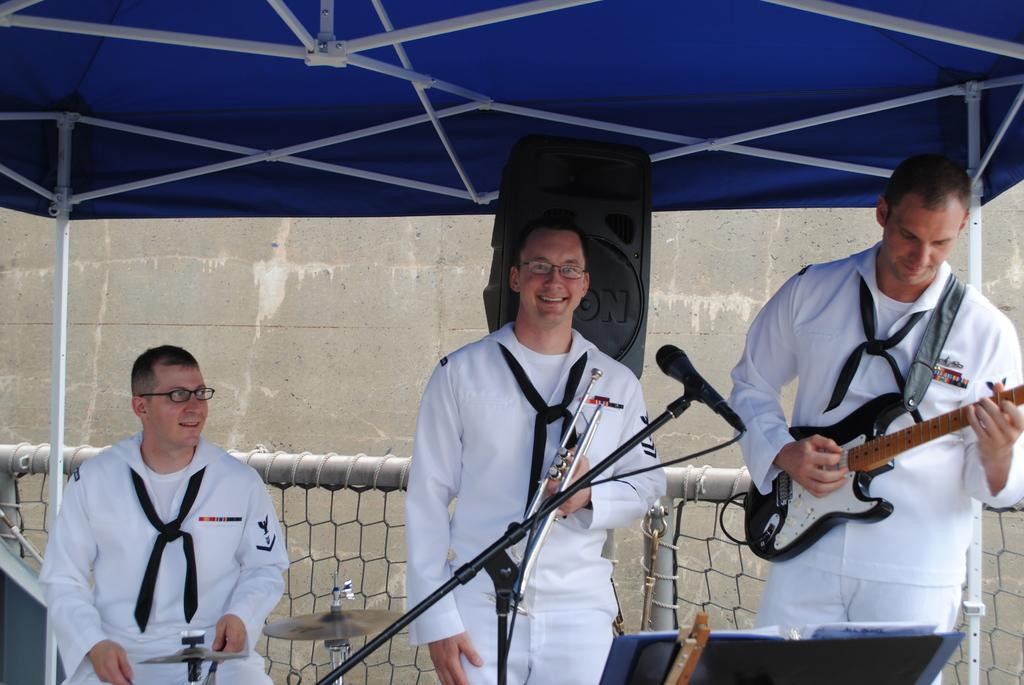How many people are in the image? There are three persons in the image. What are the persons doing in the image? The persons are playing musical instruments. Can you describe any equipment related to sound in the image? Yes, there is a microphone in the image. What can be seen in the background of the image? There is a wall and a mesh in the background of the image. Is there a fight happening between the persons in the image? No, there is no fight depicted in the image; the persons are playing musical instruments. What type of poison is being used by the person holding the guitar in the image? There is no poison present in the image; the person is playing a musical instrument. 